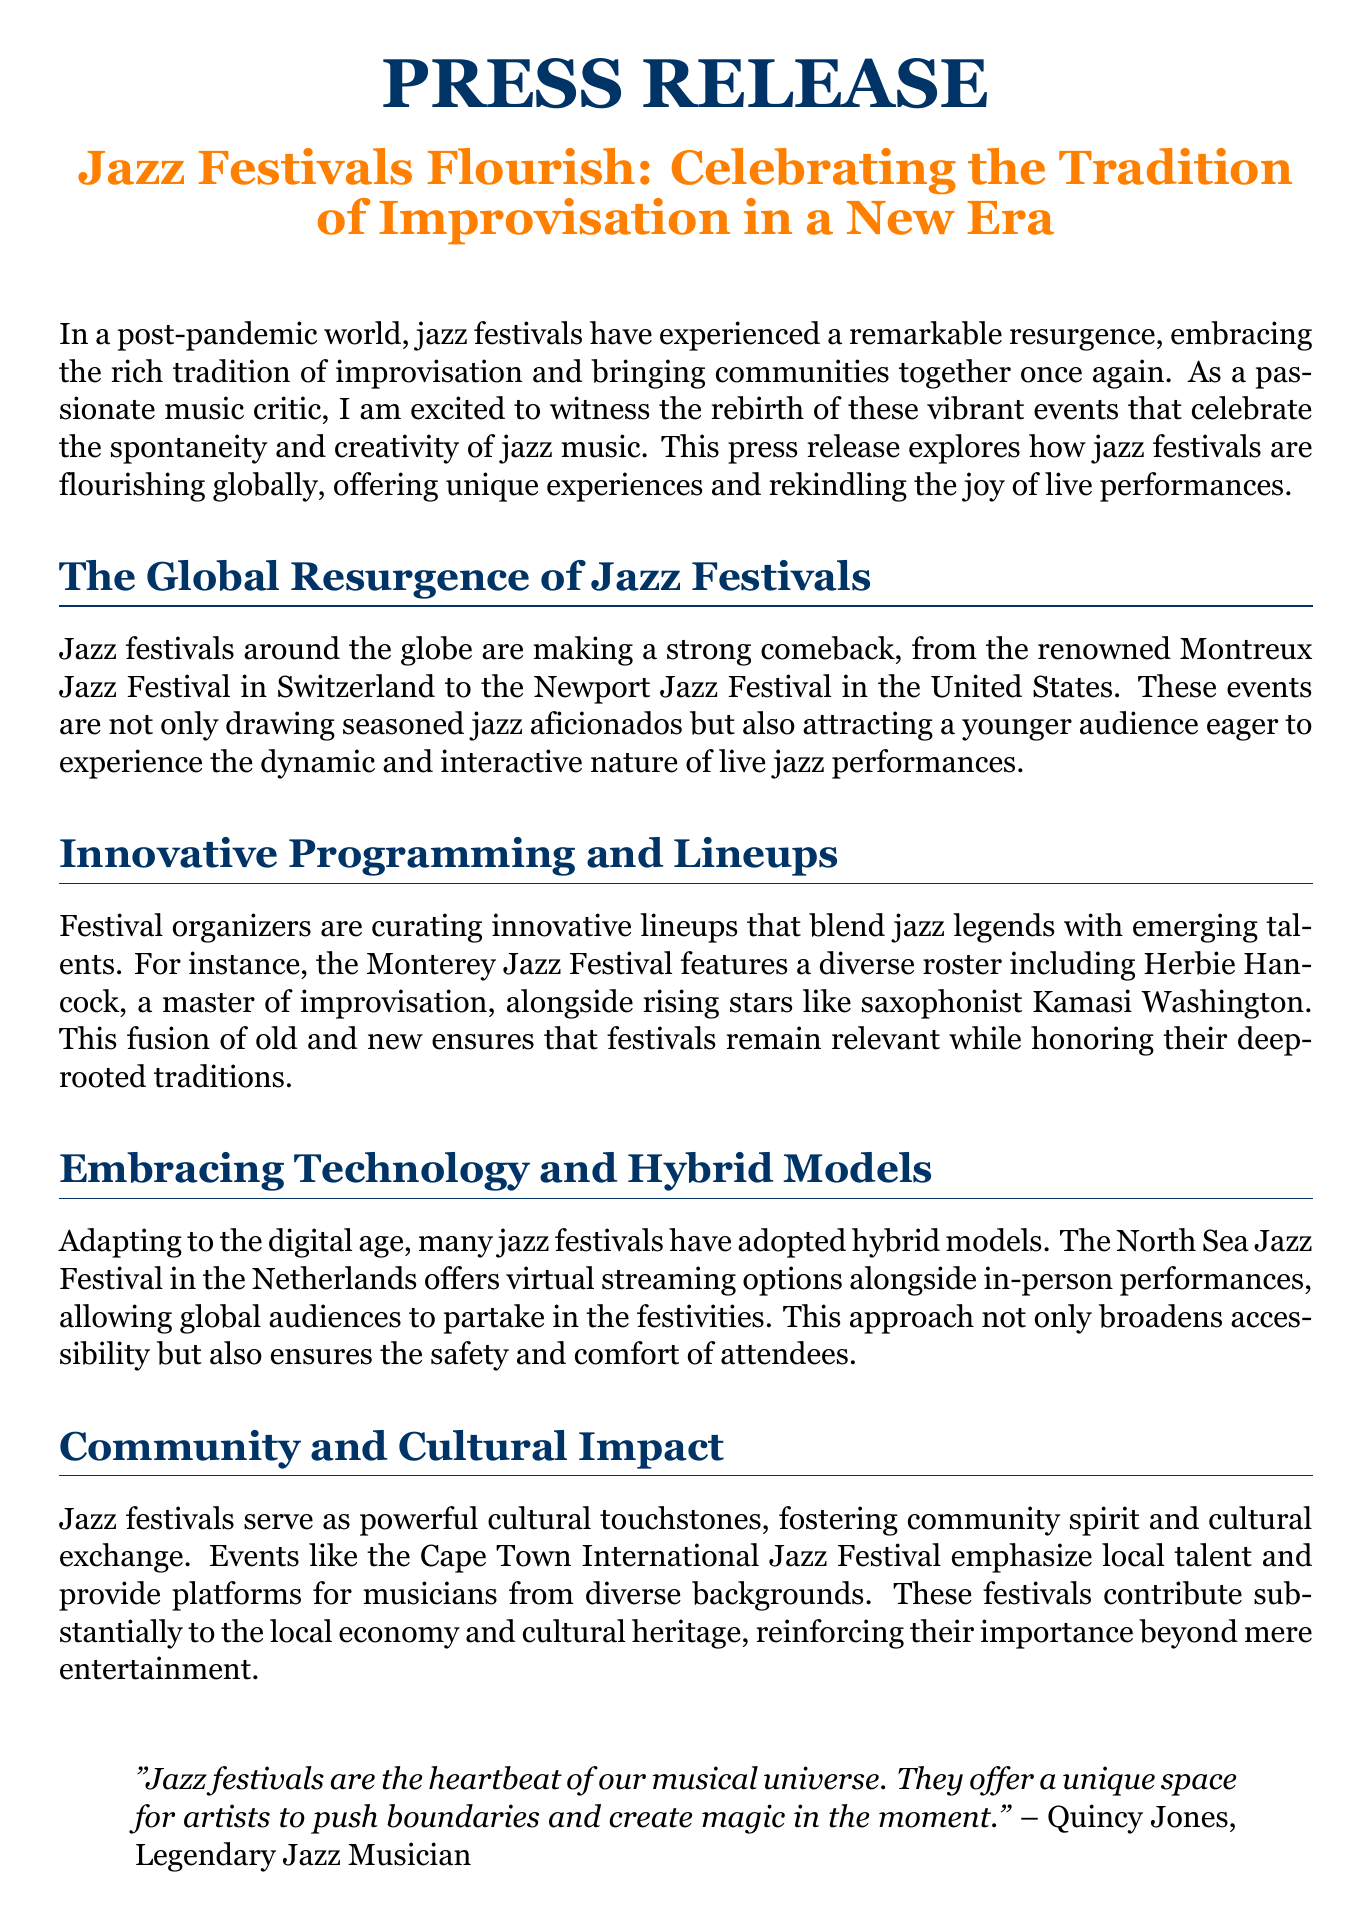What is the title of the press release? The title is clearly stated at the beginning of the document.
Answer: Jazz Festivals Flourish: Celebrating the Tradition of Improvisation in a New Era Which festival is mentioned as taking place in Switzerland? The document explicitly names the festival located in Switzerland.
Answer: Montreux Jazz Festival What is the unique feature of the North Sea Jazz Festival? The press release outlines a specific aspect of this festival that adapts to modern times.
Answer: Virtual streaming options Who is quoted as saying, "Jazz festivals are the heartbeat of our musical universe"? The quote is attributed to a well-known musician mentioned in the document.
Answer: Quincy Jones Which jazz musician is highlighted alongside rising stars at the Monterey Jazz Festival? The document provides the name of a prominent jazz artist featured in the festival's lineup.
Answer: Herbie Hancock What year does the director of the Montreux Jazz Festival refer to in her quote? The text describes the context of her quote, which refers to the current festival year.
Answer: This year How do jazz festivals contribute to local communities? The document emphasizes the impact of these events on the economy and cultural aspects of the community.
Answer: Cultural exchange What is the main theme celebrated by jazz festivals according to the document? The press release highlights the essential aspect that festivals focus on.
Answer: Improvisation 